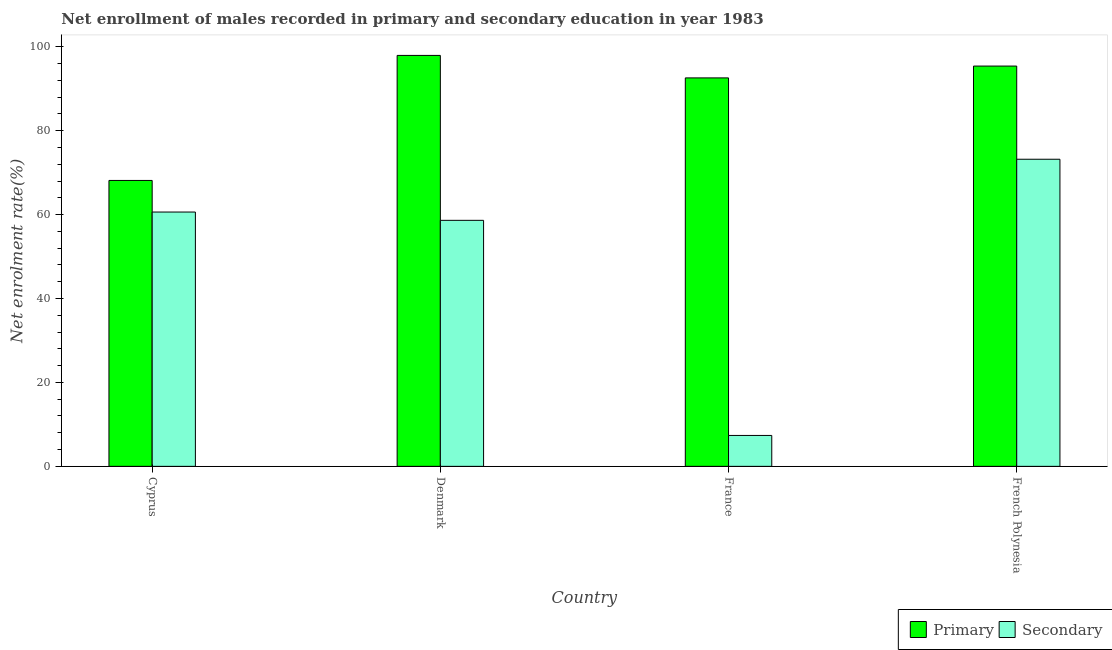How many different coloured bars are there?
Your answer should be compact. 2. How many groups of bars are there?
Ensure brevity in your answer.  4. Are the number of bars on each tick of the X-axis equal?
Your answer should be very brief. Yes. How many bars are there on the 3rd tick from the right?
Offer a terse response. 2. In how many cases, is the number of bars for a given country not equal to the number of legend labels?
Offer a very short reply. 0. What is the enrollment rate in primary education in Cyprus?
Keep it short and to the point. 68.14. Across all countries, what is the maximum enrollment rate in secondary education?
Keep it short and to the point. 73.19. Across all countries, what is the minimum enrollment rate in primary education?
Offer a terse response. 68.14. In which country was the enrollment rate in secondary education maximum?
Offer a terse response. French Polynesia. What is the total enrollment rate in primary education in the graph?
Your answer should be compact. 354.05. What is the difference between the enrollment rate in primary education in France and that in French Polynesia?
Offer a very short reply. -2.82. What is the difference between the enrollment rate in secondary education in Denmark and the enrollment rate in primary education in France?
Your response must be concise. -33.95. What is the average enrollment rate in secondary education per country?
Your answer should be very brief. 49.95. What is the difference between the enrollment rate in primary education and enrollment rate in secondary education in French Polynesia?
Give a very brief answer. 22.2. What is the ratio of the enrollment rate in secondary education in Cyprus to that in France?
Your answer should be very brief. 8.23. Is the enrollment rate in secondary education in Cyprus less than that in Denmark?
Provide a short and direct response. No. Is the difference between the enrollment rate in primary education in Denmark and French Polynesia greater than the difference between the enrollment rate in secondary education in Denmark and French Polynesia?
Keep it short and to the point. Yes. What is the difference between the highest and the second highest enrollment rate in primary education?
Your response must be concise. 2.54. What is the difference between the highest and the lowest enrollment rate in secondary education?
Ensure brevity in your answer.  65.83. In how many countries, is the enrollment rate in secondary education greater than the average enrollment rate in secondary education taken over all countries?
Give a very brief answer. 3. What does the 2nd bar from the left in French Polynesia represents?
Your response must be concise. Secondary. What does the 1st bar from the right in France represents?
Your response must be concise. Secondary. Are all the bars in the graph horizontal?
Make the answer very short. No. Does the graph contain grids?
Ensure brevity in your answer.  No. Where does the legend appear in the graph?
Your answer should be very brief. Bottom right. What is the title of the graph?
Give a very brief answer. Net enrollment of males recorded in primary and secondary education in year 1983. Does "National Visitors" appear as one of the legend labels in the graph?
Your answer should be very brief. No. What is the label or title of the X-axis?
Offer a terse response. Country. What is the label or title of the Y-axis?
Provide a succinct answer. Net enrolment rate(%). What is the Net enrolment rate(%) in Primary in Cyprus?
Your answer should be very brief. 68.14. What is the Net enrolment rate(%) of Secondary in Cyprus?
Ensure brevity in your answer.  60.61. What is the Net enrolment rate(%) in Primary in Denmark?
Provide a short and direct response. 97.94. What is the Net enrolment rate(%) in Secondary in Denmark?
Ensure brevity in your answer.  58.63. What is the Net enrolment rate(%) in Primary in France?
Keep it short and to the point. 92.58. What is the Net enrolment rate(%) in Secondary in France?
Ensure brevity in your answer.  7.37. What is the Net enrolment rate(%) of Primary in French Polynesia?
Your answer should be very brief. 95.4. What is the Net enrolment rate(%) of Secondary in French Polynesia?
Your response must be concise. 73.19. Across all countries, what is the maximum Net enrolment rate(%) in Primary?
Your answer should be very brief. 97.94. Across all countries, what is the maximum Net enrolment rate(%) in Secondary?
Provide a short and direct response. 73.19. Across all countries, what is the minimum Net enrolment rate(%) in Primary?
Provide a short and direct response. 68.14. Across all countries, what is the minimum Net enrolment rate(%) in Secondary?
Keep it short and to the point. 7.37. What is the total Net enrolment rate(%) of Primary in the graph?
Provide a short and direct response. 354.05. What is the total Net enrolment rate(%) of Secondary in the graph?
Ensure brevity in your answer.  199.8. What is the difference between the Net enrolment rate(%) in Primary in Cyprus and that in Denmark?
Ensure brevity in your answer.  -29.8. What is the difference between the Net enrolment rate(%) in Secondary in Cyprus and that in Denmark?
Provide a succinct answer. 1.98. What is the difference between the Net enrolment rate(%) of Primary in Cyprus and that in France?
Your answer should be compact. -24.44. What is the difference between the Net enrolment rate(%) in Secondary in Cyprus and that in France?
Your answer should be very brief. 53.24. What is the difference between the Net enrolment rate(%) of Primary in Cyprus and that in French Polynesia?
Your response must be concise. -27.26. What is the difference between the Net enrolment rate(%) in Secondary in Cyprus and that in French Polynesia?
Keep it short and to the point. -12.58. What is the difference between the Net enrolment rate(%) of Primary in Denmark and that in France?
Ensure brevity in your answer.  5.36. What is the difference between the Net enrolment rate(%) of Secondary in Denmark and that in France?
Make the answer very short. 51.26. What is the difference between the Net enrolment rate(%) of Primary in Denmark and that in French Polynesia?
Ensure brevity in your answer.  2.54. What is the difference between the Net enrolment rate(%) of Secondary in Denmark and that in French Polynesia?
Make the answer very short. -14.56. What is the difference between the Net enrolment rate(%) in Primary in France and that in French Polynesia?
Provide a succinct answer. -2.82. What is the difference between the Net enrolment rate(%) of Secondary in France and that in French Polynesia?
Make the answer very short. -65.83. What is the difference between the Net enrolment rate(%) in Primary in Cyprus and the Net enrolment rate(%) in Secondary in Denmark?
Make the answer very short. 9.51. What is the difference between the Net enrolment rate(%) in Primary in Cyprus and the Net enrolment rate(%) in Secondary in France?
Your answer should be very brief. 60.77. What is the difference between the Net enrolment rate(%) in Primary in Cyprus and the Net enrolment rate(%) in Secondary in French Polynesia?
Offer a very short reply. -5.05. What is the difference between the Net enrolment rate(%) in Primary in Denmark and the Net enrolment rate(%) in Secondary in France?
Offer a very short reply. 90.57. What is the difference between the Net enrolment rate(%) of Primary in Denmark and the Net enrolment rate(%) of Secondary in French Polynesia?
Keep it short and to the point. 24.74. What is the difference between the Net enrolment rate(%) in Primary in France and the Net enrolment rate(%) in Secondary in French Polynesia?
Make the answer very short. 19.39. What is the average Net enrolment rate(%) in Primary per country?
Make the answer very short. 88.51. What is the average Net enrolment rate(%) in Secondary per country?
Keep it short and to the point. 49.95. What is the difference between the Net enrolment rate(%) in Primary and Net enrolment rate(%) in Secondary in Cyprus?
Offer a very short reply. 7.53. What is the difference between the Net enrolment rate(%) in Primary and Net enrolment rate(%) in Secondary in Denmark?
Offer a very short reply. 39.31. What is the difference between the Net enrolment rate(%) of Primary and Net enrolment rate(%) of Secondary in France?
Ensure brevity in your answer.  85.21. What is the difference between the Net enrolment rate(%) of Primary and Net enrolment rate(%) of Secondary in French Polynesia?
Keep it short and to the point. 22.2. What is the ratio of the Net enrolment rate(%) of Primary in Cyprus to that in Denmark?
Provide a succinct answer. 0.7. What is the ratio of the Net enrolment rate(%) in Secondary in Cyprus to that in Denmark?
Your response must be concise. 1.03. What is the ratio of the Net enrolment rate(%) in Primary in Cyprus to that in France?
Keep it short and to the point. 0.74. What is the ratio of the Net enrolment rate(%) of Secondary in Cyprus to that in France?
Provide a succinct answer. 8.23. What is the ratio of the Net enrolment rate(%) in Secondary in Cyprus to that in French Polynesia?
Your answer should be very brief. 0.83. What is the ratio of the Net enrolment rate(%) in Primary in Denmark to that in France?
Your response must be concise. 1.06. What is the ratio of the Net enrolment rate(%) of Secondary in Denmark to that in France?
Give a very brief answer. 7.96. What is the ratio of the Net enrolment rate(%) of Primary in Denmark to that in French Polynesia?
Your answer should be compact. 1.03. What is the ratio of the Net enrolment rate(%) of Secondary in Denmark to that in French Polynesia?
Offer a terse response. 0.8. What is the ratio of the Net enrolment rate(%) of Primary in France to that in French Polynesia?
Provide a succinct answer. 0.97. What is the ratio of the Net enrolment rate(%) in Secondary in France to that in French Polynesia?
Make the answer very short. 0.1. What is the difference between the highest and the second highest Net enrolment rate(%) in Primary?
Your response must be concise. 2.54. What is the difference between the highest and the second highest Net enrolment rate(%) in Secondary?
Your response must be concise. 12.58. What is the difference between the highest and the lowest Net enrolment rate(%) in Primary?
Provide a succinct answer. 29.8. What is the difference between the highest and the lowest Net enrolment rate(%) of Secondary?
Your response must be concise. 65.83. 